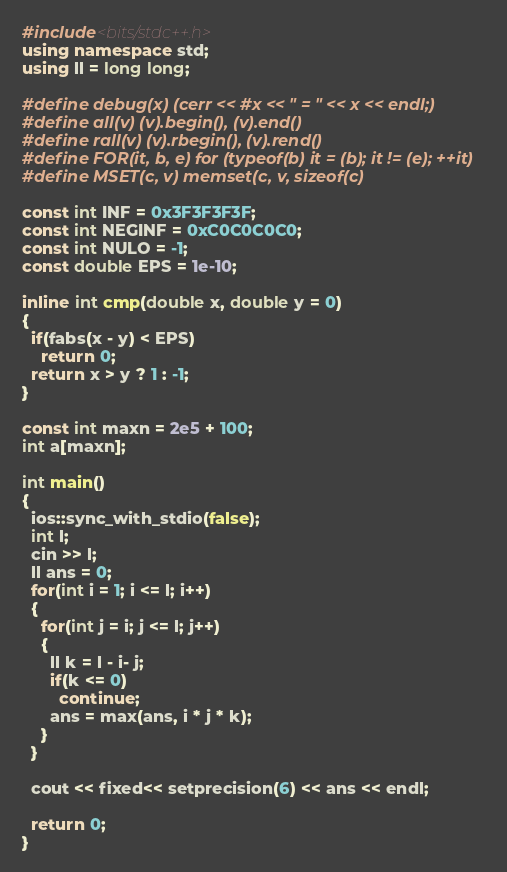Convert code to text. <code><loc_0><loc_0><loc_500><loc_500><_C++_>#include<bits/stdc++.h>
using namespace std;
using ll = long long;

#define debug(x) (cerr << #x << " = " << x << endl;)
#define all(v) (v).begin(), (v).end()
#define rall(v) (v).rbegin(), (v).rend()
#define FOR(it, b, e) for (typeof(b) it = (b); it != (e); ++it)
#define MSET(c, v) memset(c, v, sizeof(c)

const int INF = 0x3F3F3F3F; 
const int NEGINF = 0xC0C0C0C0;
const int NULO = -1;
const double EPS = 1e-10;

inline int cmp(double x, double y = 0) 
{  
  if(fabs(x - y) < EPS)
    return 0;
  return x > y ? 1 : -1;
}

const int maxn = 2e5 + 100;
int a[maxn];

int main()
{
  ios::sync_with_stdio(false);
  int l;
  cin >> l;
  ll ans = 0;
  for(int i = 1; i <= l; i++)
  {
    for(int j = i; j <= l; j++)
    {
      ll k = l - i- j;
      if(k <= 0)
        continue;
      ans = max(ans, i * j * k);
    }
  }

  cout << fixed<< setprecision(6) << ans << endl;

  return 0;
}</code> 